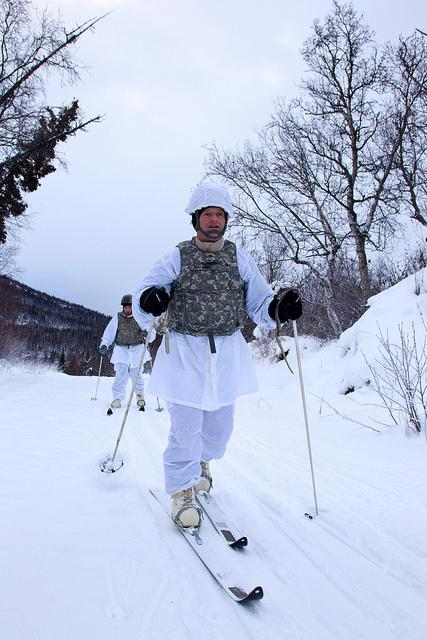Why does he have on that type of vest? Please explain your reasoning. blending in. The man's clothes are the same color as the snow. 